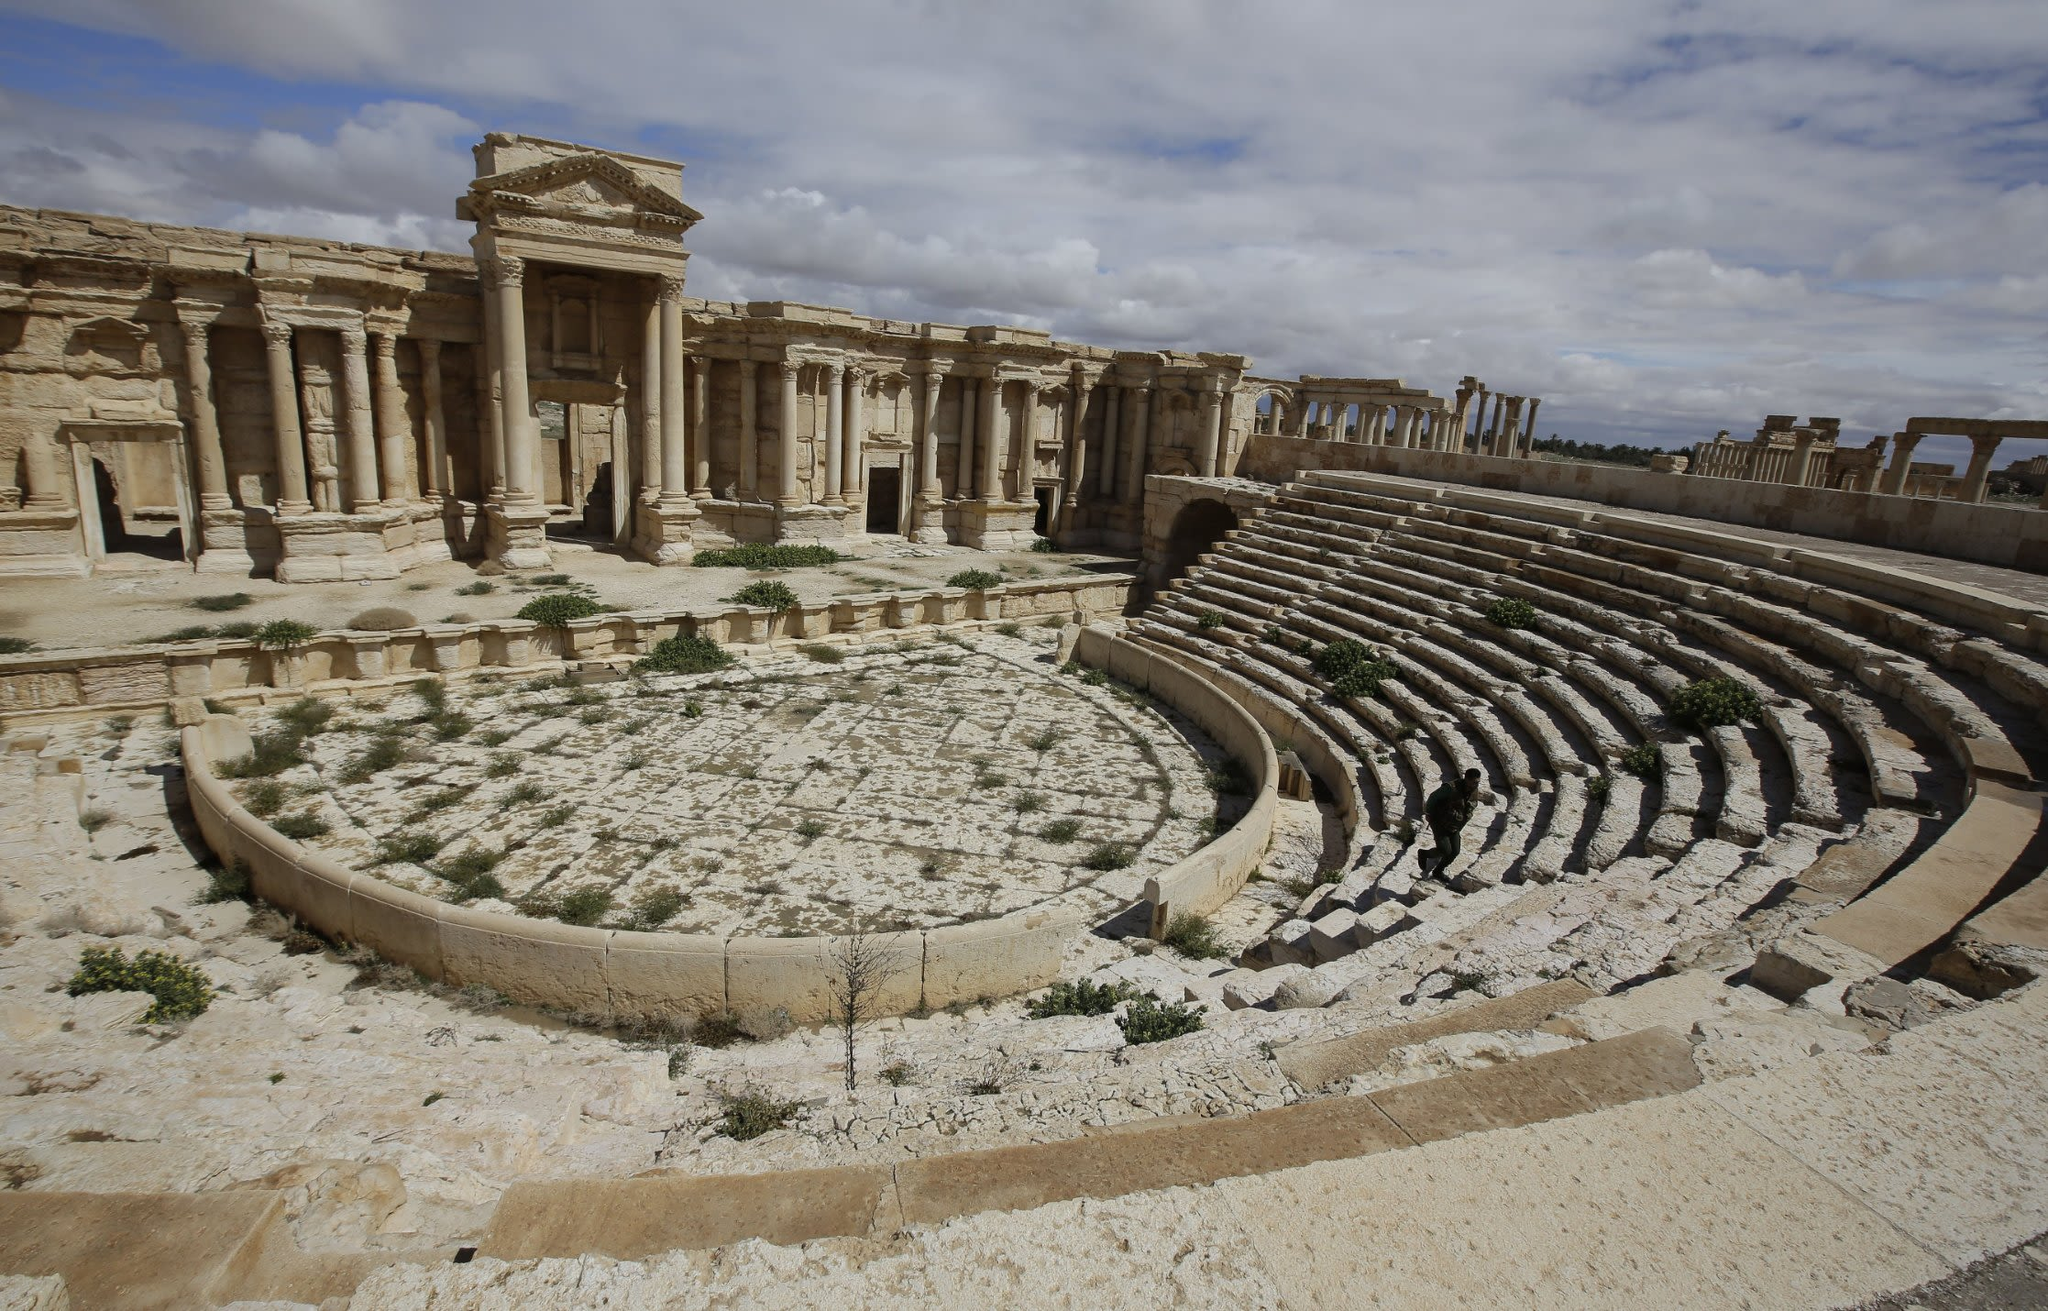Imagine standing in the middle of this ancient theater during its peak use. What might you hear, see, and feel? Standing in the middle of this ancient theater during its heyday, you would be enveloped by a symphony of sounds: the robust applause and cheers of a captivated audience, the resonant voices of actors articulating grand tales, and the rhythmic clatter of sandals against the meticulous stone seating. Visually, the scene would be vibrant with the colorful attire of Roman spectators filling the semi-circular tiers, while the stage itself would be adorned with elaborate props and backdrops, illustrating dramatic scenes. The air would be electric with anticipation and excitement, mingled with the faint scent of fresh foliage and incense. The warmth of the sun would contrast with the coolness of the stone beneath your feet, grounding you in this awe-inspiring spectacle of ancient cultural grandeur. 